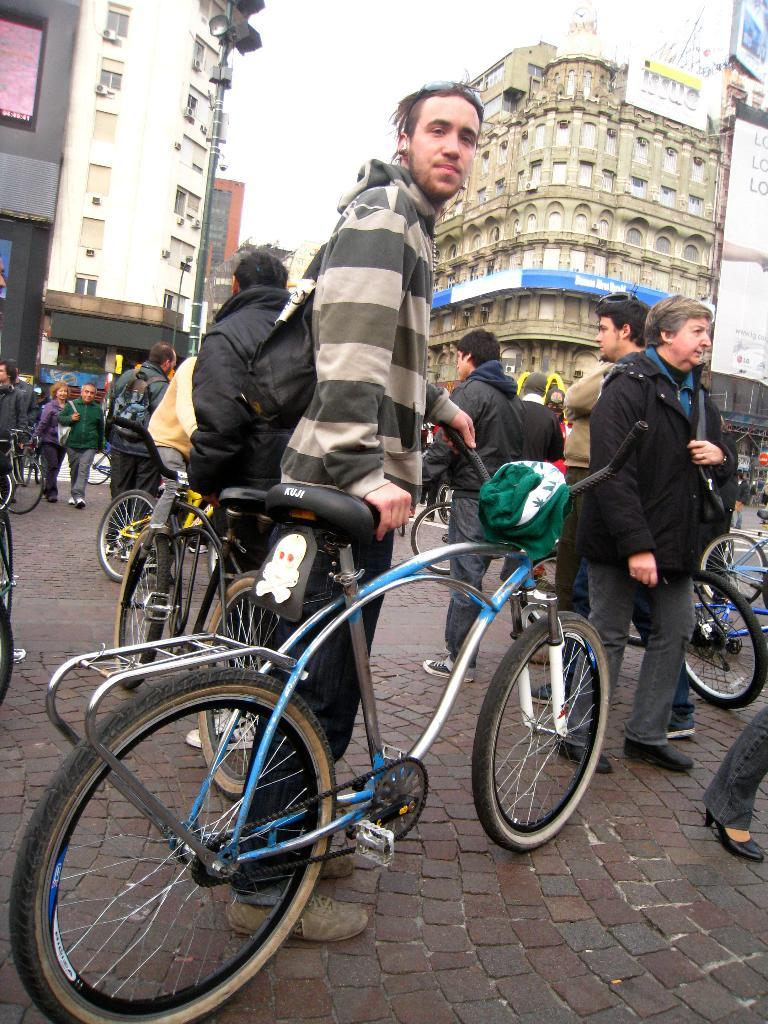What is the main subject of the image? There is a man standing in the image. What can be seen in the background of the image? There is a building in the background of the image. How would you describe the weather in the image? The sky is clear in the image, suggesting good weather. What type of animal can be seen hiding in the cave in the image? There is no cave or animal present in the image; it features a man standing in front of a building with a clear sky. 